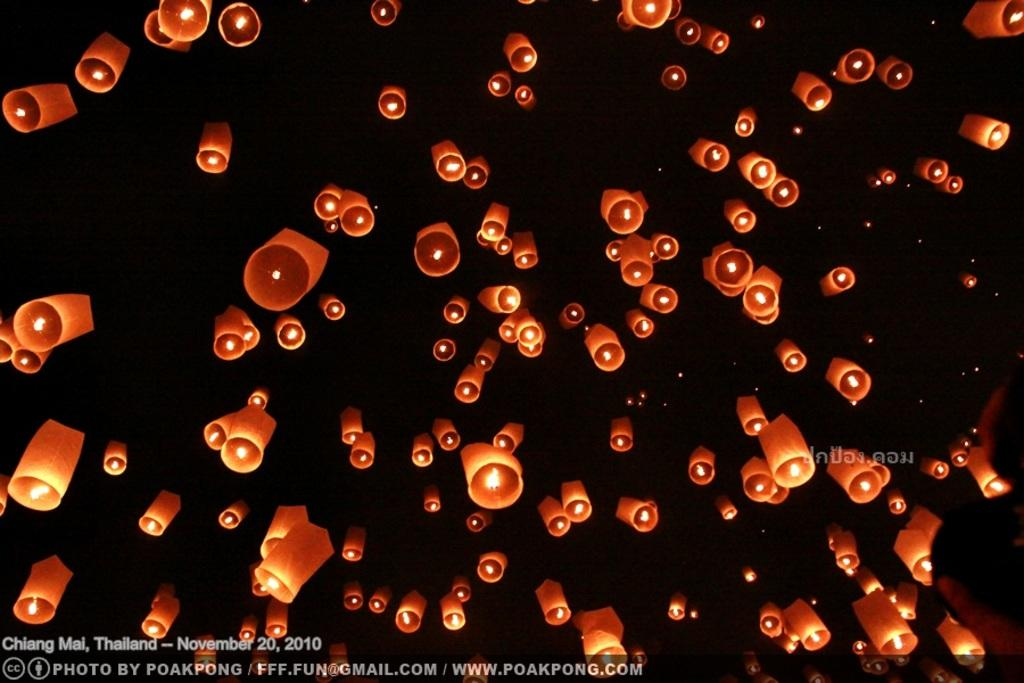What type of lighting is present in the image? There are lanterns in the image. What color are the lanterns? The lanterns are orange in color. What is the color of the background in the image? The background in the image is black. Is there any text or logo visible in the image? Yes, there is a watermark in the image. What type of cord is used to hang the lanterns in the image? There is no visible cord used to hang the lanterns in the image. 